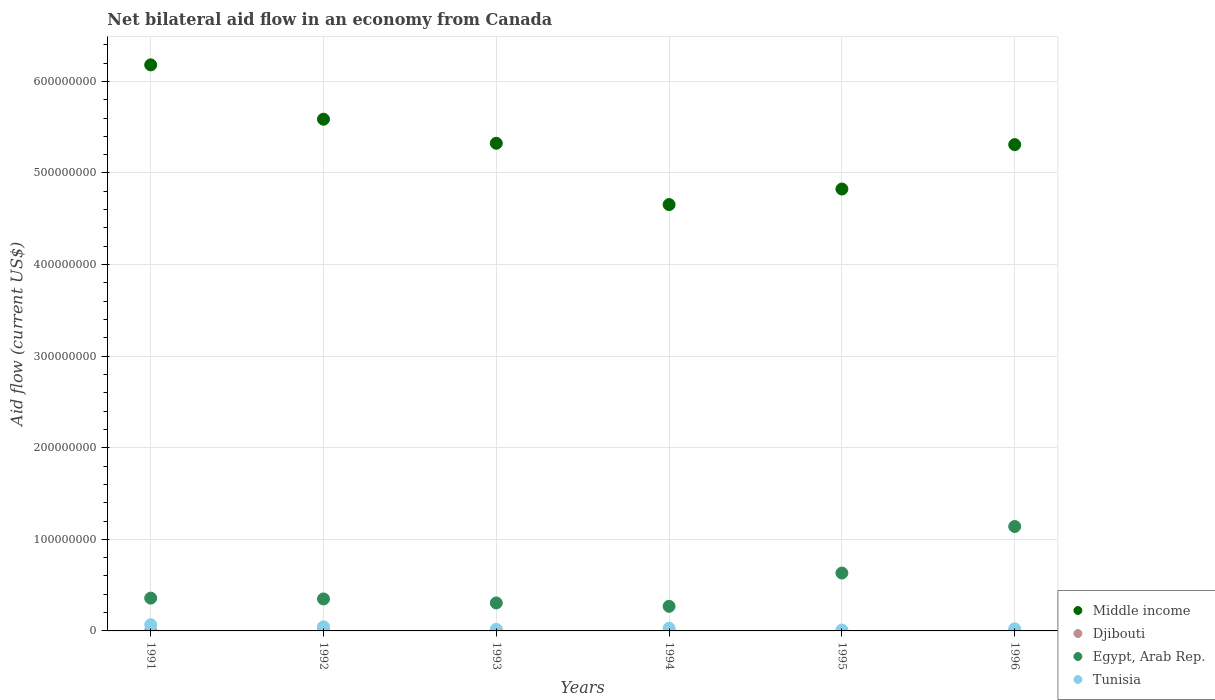How many different coloured dotlines are there?
Offer a very short reply. 4. What is the net bilateral aid flow in Tunisia in 1992?
Your answer should be very brief. 4.51e+06. Across all years, what is the maximum net bilateral aid flow in Tunisia?
Offer a terse response. 6.78e+06. Across all years, what is the minimum net bilateral aid flow in Tunisia?
Ensure brevity in your answer.  9.30e+05. In which year was the net bilateral aid flow in Egypt, Arab Rep. maximum?
Offer a very short reply. 1996. In which year was the net bilateral aid flow in Middle income minimum?
Ensure brevity in your answer.  1994. What is the total net bilateral aid flow in Djibouti in the graph?
Provide a short and direct response. 1.22e+06. What is the difference between the net bilateral aid flow in Djibouti in 1991 and that in 1992?
Your answer should be very brief. -2.40e+05. What is the difference between the net bilateral aid flow in Middle income in 1994 and the net bilateral aid flow in Egypt, Arab Rep. in 1992?
Make the answer very short. 4.31e+08. What is the average net bilateral aid flow in Egypt, Arab Rep. per year?
Your answer should be compact. 5.09e+07. In the year 1992, what is the difference between the net bilateral aid flow in Djibouti and net bilateral aid flow in Egypt, Arab Rep.?
Your answer should be compact. -3.45e+07. What is the ratio of the net bilateral aid flow in Djibouti in 1993 to that in 1996?
Ensure brevity in your answer.  1.47. Is the net bilateral aid flow in Middle income in 1994 less than that in 1995?
Offer a very short reply. Yes. Is the difference between the net bilateral aid flow in Djibouti in 1993 and 1996 greater than the difference between the net bilateral aid flow in Egypt, Arab Rep. in 1993 and 1996?
Your answer should be very brief. Yes. What is the difference between the highest and the lowest net bilateral aid flow in Middle income?
Provide a succinct answer. 1.53e+08. Is it the case that in every year, the sum of the net bilateral aid flow in Tunisia and net bilateral aid flow in Egypt, Arab Rep.  is greater than the net bilateral aid flow in Middle income?
Provide a succinct answer. No. Is the net bilateral aid flow in Egypt, Arab Rep. strictly greater than the net bilateral aid flow in Djibouti over the years?
Your answer should be compact. Yes. Is the net bilateral aid flow in Tunisia strictly less than the net bilateral aid flow in Djibouti over the years?
Your answer should be compact. No. How many dotlines are there?
Provide a short and direct response. 4. What is the difference between two consecutive major ticks on the Y-axis?
Provide a succinct answer. 1.00e+08. Are the values on the major ticks of Y-axis written in scientific E-notation?
Offer a terse response. No. Does the graph contain any zero values?
Your answer should be very brief. No. Does the graph contain grids?
Your answer should be compact. Yes. How many legend labels are there?
Provide a short and direct response. 4. How are the legend labels stacked?
Provide a short and direct response. Vertical. What is the title of the graph?
Keep it short and to the point. Net bilateral aid flow in an economy from Canada. Does "Papua New Guinea" appear as one of the legend labels in the graph?
Keep it short and to the point. No. What is the label or title of the X-axis?
Your answer should be compact. Years. What is the label or title of the Y-axis?
Your response must be concise. Aid flow (current US$). What is the Aid flow (current US$) of Middle income in 1991?
Your answer should be compact. 6.18e+08. What is the Aid flow (current US$) of Egypt, Arab Rep. in 1991?
Provide a succinct answer. 3.58e+07. What is the Aid flow (current US$) in Tunisia in 1991?
Offer a terse response. 6.78e+06. What is the Aid flow (current US$) in Middle income in 1992?
Offer a terse response. 5.59e+08. What is the Aid flow (current US$) of Egypt, Arab Rep. in 1992?
Give a very brief answer. 3.49e+07. What is the Aid flow (current US$) in Tunisia in 1992?
Offer a terse response. 4.51e+06. What is the Aid flow (current US$) of Middle income in 1993?
Make the answer very short. 5.32e+08. What is the Aid flow (current US$) in Djibouti in 1993?
Keep it short and to the point. 2.20e+05. What is the Aid flow (current US$) of Egypt, Arab Rep. in 1993?
Offer a very short reply. 3.05e+07. What is the Aid flow (current US$) of Tunisia in 1993?
Your response must be concise. 1.77e+06. What is the Aid flow (current US$) in Middle income in 1994?
Ensure brevity in your answer.  4.66e+08. What is the Aid flow (current US$) of Djibouti in 1994?
Make the answer very short. 1.30e+05. What is the Aid flow (current US$) of Egypt, Arab Rep. in 1994?
Give a very brief answer. 2.69e+07. What is the Aid flow (current US$) in Tunisia in 1994?
Your answer should be compact. 2.89e+06. What is the Aid flow (current US$) in Middle income in 1995?
Provide a short and direct response. 4.82e+08. What is the Aid flow (current US$) of Djibouti in 1995?
Your response must be concise. 1.40e+05. What is the Aid flow (current US$) in Egypt, Arab Rep. in 1995?
Offer a very short reply. 6.32e+07. What is the Aid flow (current US$) in Tunisia in 1995?
Provide a short and direct response. 9.30e+05. What is the Aid flow (current US$) in Middle income in 1996?
Your response must be concise. 5.31e+08. What is the Aid flow (current US$) in Egypt, Arab Rep. in 1996?
Make the answer very short. 1.14e+08. What is the Aid flow (current US$) of Tunisia in 1996?
Ensure brevity in your answer.  2.28e+06. Across all years, what is the maximum Aid flow (current US$) in Middle income?
Your answer should be very brief. 6.18e+08. Across all years, what is the maximum Aid flow (current US$) in Egypt, Arab Rep.?
Provide a succinct answer. 1.14e+08. Across all years, what is the maximum Aid flow (current US$) in Tunisia?
Provide a short and direct response. 6.78e+06. Across all years, what is the minimum Aid flow (current US$) of Middle income?
Make the answer very short. 4.66e+08. Across all years, what is the minimum Aid flow (current US$) in Djibouti?
Provide a succinct answer. 1.30e+05. Across all years, what is the minimum Aid flow (current US$) in Egypt, Arab Rep.?
Ensure brevity in your answer.  2.69e+07. Across all years, what is the minimum Aid flow (current US$) of Tunisia?
Provide a succinct answer. 9.30e+05. What is the total Aid flow (current US$) of Middle income in the graph?
Provide a short and direct response. 3.19e+09. What is the total Aid flow (current US$) in Djibouti in the graph?
Keep it short and to the point. 1.22e+06. What is the total Aid flow (current US$) of Egypt, Arab Rep. in the graph?
Provide a short and direct response. 3.05e+08. What is the total Aid flow (current US$) of Tunisia in the graph?
Your answer should be very brief. 1.92e+07. What is the difference between the Aid flow (current US$) of Middle income in 1991 and that in 1992?
Your response must be concise. 5.93e+07. What is the difference between the Aid flow (current US$) in Egypt, Arab Rep. in 1991 and that in 1992?
Make the answer very short. 9.00e+05. What is the difference between the Aid flow (current US$) in Tunisia in 1991 and that in 1992?
Your answer should be compact. 2.27e+06. What is the difference between the Aid flow (current US$) in Middle income in 1991 and that in 1993?
Provide a short and direct response. 8.56e+07. What is the difference between the Aid flow (current US$) of Egypt, Arab Rep. in 1991 and that in 1993?
Your response must be concise. 5.28e+06. What is the difference between the Aid flow (current US$) of Tunisia in 1991 and that in 1993?
Keep it short and to the point. 5.01e+06. What is the difference between the Aid flow (current US$) of Middle income in 1991 and that in 1994?
Your response must be concise. 1.53e+08. What is the difference between the Aid flow (current US$) in Djibouti in 1991 and that in 1994?
Your response must be concise. 4.00e+04. What is the difference between the Aid flow (current US$) in Egypt, Arab Rep. in 1991 and that in 1994?
Your answer should be very brief. 8.95e+06. What is the difference between the Aid flow (current US$) in Tunisia in 1991 and that in 1994?
Ensure brevity in your answer.  3.89e+06. What is the difference between the Aid flow (current US$) in Middle income in 1991 and that in 1995?
Provide a short and direct response. 1.36e+08. What is the difference between the Aid flow (current US$) of Djibouti in 1991 and that in 1995?
Make the answer very short. 3.00e+04. What is the difference between the Aid flow (current US$) of Egypt, Arab Rep. in 1991 and that in 1995?
Make the answer very short. -2.74e+07. What is the difference between the Aid flow (current US$) of Tunisia in 1991 and that in 1995?
Keep it short and to the point. 5.85e+06. What is the difference between the Aid flow (current US$) of Middle income in 1991 and that in 1996?
Your answer should be compact. 8.71e+07. What is the difference between the Aid flow (current US$) of Djibouti in 1991 and that in 1996?
Your answer should be compact. 2.00e+04. What is the difference between the Aid flow (current US$) of Egypt, Arab Rep. in 1991 and that in 1996?
Provide a succinct answer. -7.82e+07. What is the difference between the Aid flow (current US$) in Tunisia in 1991 and that in 1996?
Provide a short and direct response. 4.50e+06. What is the difference between the Aid flow (current US$) of Middle income in 1992 and that in 1993?
Your answer should be very brief. 2.63e+07. What is the difference between the Aid flow (current US$) in Djibouti in 1992 and that in 1993?
Provide a succinct answer. 1.90e+05. What is the difference between the Aid flow (current US$) in Egypt, Arab Rep. in 1992 and that in 1993?
Ensure brevity in your answer.  4.38e+06. What is the difference between the Aid flow (current US$) in Tunisia in 1992 and that in 1993?
Your answer should be very brief. 2.74e+06. What is the difference between the Aid flow (current US$) of Middle income in 1992 and that in 1994?
Make the answer very short. 9.32e+07. What is the difference between the Aid flow (current US$) of Djibouti in 1992 and that in 1994?
Offer a very short reply. 2.80e+05. What is the difference between the Aid flow (current US$) of Egypt, Arab Rep. in 1992 and that in 1994?
Provide a short and direct response. 8.05e+06. What is the difference between the Aid flow (current US$) of Tunisia in 1992 and that in 1994?
Offer a very short reply. 1.62e+06. What is the difference between the Aid flow (current US$) in Middle income in 1992 and that in 1995?
Ensure brevity in your answer.  7.62e+07. What is the difference between the Aid flow (current US$) of Egypt, Arab Rep. in 1992 and that in 1995?
Give a very brief answer. -2.83e+07. What is the difference between the Aid flow (current US$) in Tunisia in 1992 and that in 1995?
Provide a succinct answer. 3.58e+06. What is the difference between the Aid flow (current US$) in Middle income in 1992 and that in 1996?
Make the answer very short. 2.78e+07. What is the difference between the Aid flow (current US$) of Egypt, Arab Rep. in 1992 and that in 1996?
Offer a very short reply. -7.91e+07. What is the difference between the Aid flow (current US$) in Tunisia in 1992 and that in 1996?
Ensure brevity in your answer.  2.23e+06. What is the difference between the Aid flow (current US$) of Middle income in 1993 and that in 1994?
Make the answer very short. 6.69e+07. What is the difference between the Aid flow (current US$) of Djibouti in 1993 and that in 1994?
Give a very brief answer. 9.00e+04. What is the difference between the Aid flow (current US$) of Egypt, Arab Rep. in 1993 and that in 1994?
Your answer should be compact. 3.67e+06. What is the difference between the Aid flow (current US$) in Tunisia in 1993 and that in 1994?
Give a very brief answer. -1.12e+06. What is the difference between the Aid flow (current US$) of Middle income in 1993 and that in 1995?
Keep it short and to the point. 4.99e+07. What is the difference between the Aid flow (current US$) in Egypt, Arab Rep. in 1993 and that in 1995?
Provide a succinct answer. -3.26e+07. What is the difference between the Aid flow (current US$) of Tunisia in 1993 and that in 1995?
Provide a succinct answer. 8.40e+05. What is the difference between the Aid flow (current US$) in Middle income in 1993 and that in 1996?
Offer a terse response. 1.48e+06. What is the difference between the Aid flow (current US$) in Djibouti in 1993 and that in 1996?
Provide a succinct answer. 7.00e+04. What is the difference between the Aid flow (current US$) of Egypt, Arab Rep. in 1993 and that in 1996?
Keep it short and to the point. -8.35e+07. What is the difference between the Aid flow (current US$) of Tunisia in 1993 and that in 1996?
Make the answer very short. -5.10e+05. What is the difference between the Aid flow (current US$) in Middle income in 1994 and that in 1995?
Your response must be concise. -1.70e+07. What is the difference between the Aid flow (current US$) in Egypt, Arab Rep. in 1994 and that in 1995?
Keep it short and to the point. -3.63e+07. What is the difference between the Aid flow (current US$) in Tunisia in 1994 and that in 1995?
Keep it short and to the point. 1.96e+06. What is the difference between the Aid flow (current US$) in Middle income in 1994 and that in 1996?
Give a very brief answer. -6.54e+07. What is the difference between the Aid flow (current US$) of Djibouti in 1994 and that in 1996?
Your answer should be very brief. -2.00e+04. What is the difference between the Aid flow (current US$) in Egypt, Arab Rep. in 1994 and that in 1996?
Your response must be concise. -8.72e+07. What is the difference between the Aid flow (current US$) of Tunisia in 1994 and that in 1996?
Offer a terse response. 6.10e+05. What is the difference between the Aid flow (current US$) of Middle income in 1995 and that in 1996?
Ensure brevity in your answer.  -4.85e+07. What is the difference between the Aid flow (current US$) in Djibouti in 1995 and that in 1996?
Provide a short and direct response. -10000. What is the difference between the Aid flow (current US$) in Egypt, Arab Rep. in 1995 and that in 1996?
Keep it short and to the point. -5.08e+07. What is the difference between the Aid flow (current US$) in Tunisia in 1995 and that in 1996?
Provide a short and direct response. -1.35e+06. What is the difference between the Aid flow (current US$) in Middle income in 1991 and the Aid flow (current US$) in Djibouti in 1992?
Offer a terse response. 6.18e+08. What is the difference between the Aid flow (current US$) in Middle income in 1991 and the Aid flow (current US$) in Egypt, Arab Rep. in 1992?
Give a very brief answer. 5.83e+08. What is the difference between the Aid flow (current US$) of Middle income in 1991 and the Aid flow (current US$) of Tunisia in 1992?
Provide a succinct answer. 6.14e+08. What is the difference between the Aid flow (current US$) in Djibouti in 1991 and the Aid flow (current US$) in Egypt, Arab Rep. in 1992?
Offer a terse response. -3.48e+07. What is the difference between the Aid flow (current US$) in Djibouti in 1991 and the Aid flow (current US$) in Tunisia in 1992?
Keep it short and to the point. -4.34e+06. What is the difference between the Aid flow (current US$) of Egypt, Arab Rep. in 1991 and the Aid flow (current US$) of Tunisia in 1992?
Make the answer very short. 3.13e+07. What is the difference between the Aid flow (current US$) of Middle income in 1991 and the Aid flow (current US$) of Djibouti in 1993?
Provide a short and direct response. 6.18e+08. What is the difference between the Aid flow (current US$) of Middle income in 1991 and the Aid flow (current US$) of Egypt, Arab Rep. in 1993?
Give a very brief answer. 5.87e+08. What is the difference between the Aid flow (current US$) of Middle income in 1991 and the Aid flow (current US$) of Tunisia in 1993?
Provide a short and direct response. 6.16e+08. What is the difference between the Aid flow (current US$) of Djibouti in 1991 and the Aid flow (current US$) of Egypt, Arab Rep. in 1993?
Keep it short and to the point. -3.04e+07. What is the difference between the Aid flow (current US$) in Djibouti in 1991 and the Aid flow (current US$) in Tunisia in 1993?
Offer a terse response. -1.60e+06. What is the difference between the Aid flow (current US$) of Egypt, Arab Rep. in 1991 and the Aid flow (current US$) of Tunisia in 1993?
Your answer should be compact. 3.40e+07. What is the difference between the Aid flow (current US$) of Middle income in 1991 and the Aid flow (current US$) of Djibouti in 1994?
Ensure brevity in your answer.  6.18e+08. What is the difference between the Aid flow (current US$) in Middle income in 1991 and the Aid flow (current US$) in Egypt, Arab Rep. in 1994?
Your response must be concise. 5.91e+08. What is the difference between the Aid flow (current US$) in Middle income in 1991 and the Aid flow (current US$) in Tunisia in 1994?
Offer a terse response. 6.15e+08. What is the difference between the Aid flow (current US$) in Djibouti in 1991 and the Aid flow (current US$) in Egypt, Arab Rep. in 1994?
Give a very brief answer. -2.67e+07. What is the difference between the Aid flow (current US$) of Djibouti in 1991 and the Aid flow (current US$) of Tunisia in 1994?
Ensure brevity in your answer.  -2.72e+06. What is the difference between the Aid flow (current US$) in Egypt, Arab Rep. in 1991 and the Aid flow (current US$) in Tunisia in 1994?
Your response must be concise. 3.29e+07. What is the difference between the Aid flow (current US$) of Middle income in 1991 and the Aid flow (current US$) of Djibouti in 1995?
Keep it short and to the point. 6.18e+08. What is the difference between the Aid flow (current US$) in Middle income in 1991 and the Aid flow (current US$) in Egypt, Arab Rep. in 1995?
Provide a short and direct response. 5.55e+08. What is the difference between the Aid flow (current US$) of Middle income in 1991 and the Aid flow (current US$) of Tunisia in 1995?
Offer a very short reply. 6.17e+08. What is the difference between the Aid flow (current US$) of Djibouti in 1991 and the Aid flow (current US$) of Egypt, Arab Rep. in 1995?
Keep it short and to the point. -6.30e+07. What is the difference between the Aid flow (current US$) of Djibouti in 1991 and the Aid flow (current US$) of Tunisia in 1995?
Give a very brief answer. -7.60e+05. What is the difference between the Aid flow (current US$) of Egypt, Arab Rep. in 1991 and the Aid flow (current US$) of Tunisia in 1995?
Give a very brief answer. 3.49e+07. What is the difference between the Aid flow (current US$) of Middle income in 1991 and the Aid flow (current US$) of Djibouti in 1996?
Offer a very short reply. 6.18e+08. What is the difference between the Aid flow (current US$) of Middle income in 1991 and the Aid flow (current US$) of Egypt, Arab Rep. in 1996?
Offer a terse response. 5.04e+08. What is the difference between the Aid flow (current US$) of Middle income in 1991 and the Aid flow (current US$) of Tunisia in 1996?
Ensure brevity in your answer.  6.16e+08. What is the difference between the Aid flow (current US$) of Djibouti in 1991 and the Aid flow (current US$) of Egypt, Arab Rep. in 1996?
Offer a terse response. -1.14e+08. What is the difference between the Aid flow (current US$) of Djibouti in 1991 and the Aid flow (current US$) of Tunisia in 1996?
Provide a succinct answer. -2.11e+06. What is the difference between the Aid flow (current US$) in Egypt, Arab Rep. in 1991 and the Aid flow (current US$) in Tunisia in 1996?
Provide a short and direct response. 3.35e+07. What is the difference between the Aid flow (current US$) of Middle income in 1992 and the Aid flow (current US$) of Djibouti in 1993?
Your response must be concise. 5.58e+08. What is the difference between the Aid flow (current US$) of Middle income in 1992 and the Aid flow (current US$) of Egypt, Arab Rep. in 1993?
Ensure brevity in your answer.  5.28e+08. What is the difference between the Aid flow (current US$) in Middle income in 1992 and the Aid flow (current US$) in Tunisia in 1993?
Your answer should be compact. 5.57e+08. What is the difference between the Aid flow (current US$) in Djibouti in 1992 and the Aid flow (current US$) in Egypt, Arab Rep. in 1993?
Provide a short and direct response. -3.01e+07. What is the difference between the Aid flow (current US$) of Djibouti in 1992 and the Aid flow (current US$) of Tunisia in 1993?
Offer a very short reply. -1.36e+06. What is the difference between the Aid flow (current US$) of Egypt, Arab Rep. in 1992 and the Aid flow (current US$) of Tunisia in 1993?
Offer a terse response. 3.32e+07. What is the difference between the Aid flow (current US$) in Middle income in 1992 and the Aid flow (current US$) in Djibouti in 1994?
Your answer should be very brief. 5.59e+08. What is the difference between the Aid flow (current US$) of Middle income in 1992 and the Aid flow (current US$) of Egypt, Arab Rep. in 1994?
Your response must be concise. 5.32e+08. What is the difference between the Aid flow (current US$) of Middle income in 1992 and the Aid flow (current US$) of Tunisia in 1994?
Keep it short and to the point. 5.56e+08. What is the difference between the Aid flow (current US$) of Djibouti in 1992 and the Aid flow (current US$) of Egypt, Arab Rep. in 1994?
Your response must be concise. -2.65e+07. What is the difference between the Aid flow (current US$) of Djibouti in 1992 and the Aid flow (current US$) of Tunisia in 1994?
Your answer should be very brief. -2.48e+06. What is the difference between the Aid flow (current US$) in Egypt, Arab Rep. in 1992 and the Aid flow (current US$) in Tunisia in 1994?
Your response must be concise. 3.20e+07. What is the difference between the Aid flow (current US$) of Middle income in 1992 and the Aid flow (current US$) of Djibouti in 1995?
Keep it short and to the point. 5.59e+08. What is the difference between the Aid flow (current US$) in Middle income in 1992 and the Aid flow (current US$) in Egypt, Arab Rep. in 1995?
Offer a very short reply. 4.96e+08. What is the difference between the Aid flow (current US$) of Middle income in 1992 and the Aid flow (current US$) of Tunisia in 1995?
Your answer should be very brief. 5.58e+08. What is the difference between the Aid flow (current US$) of Djibouti in 1992 and the Aid flow (current US$) of Egypt, Arab Rep. in 1995?
Your response must be concise. -6.28e+07. What is the difference between the Aid flow (current US$) in Djibouti in 1992 and the Aid flow (current US$) in Tunisia in 1995?
Your response must be concise. -5.20e+05. What is the difference between the Aid flow (current US$) in Egypt, Arab Rep. in 1992 and the Aid flow (current US$) in Tunisia in 1995?
Your answer should be very brief. 3.40e+07. What is the difference between the Aid flow (current US$) of Middle income in 1992 and the Aid flow (current US$) of Djibouti in 1996?
Ensure brevity in your answer.  5.59e+08. What is the difference between the Aid flow (current US$) of Middle income in 1992 and the Aid flow (current US$) of Egypt, Arab Rep. in 1996?
Your answer should be compact. 4.45e+08. What is the difference between the Aid flow (current US$) in Middle income in 1992 and the Aid flow (current US$) in Tunisia in 1996?
Your answer should be compact. 5.56e+08. What is the difference between the Aid flow (current US$) of Djibouti in 1992 and the Aid flow (current US$) of Egypt, Arab Rep. in 1996?
Make the answer very short. -1.14e+08. What is the difference between the Aid flow (current US$) of Djibouti in 1992 and the Aid flow (current US$) of Tunisia in 1996?
Keep it short and to the point. -1.87e+06. What is the difference between the Aid flow (current US$) in Egypt, Arab Rep. in 1992 and the Aid flow (current US$) in Tunisia in 1996?
Give a very brief answer. 3.26e+07. What is the difference between the Aid flow (current US$) of Middle income in 1993 and the Aid flow (current US$) of Djibouti in 1994?
Your answer should be compact. 5.32e+08. What is the difference between the Aid flow (current US$) in Middle income in 1993 and the Aid flow (current US$) in Egypt, Arab Rep. in 1994?
Offer a terse response. 5.06e+08. What is the difference between the Aid flow (current US$) of Middle income in 1993 and the Aid flow (current US$) of Tunisia in 1994?
Ensure brevity in your answer.  5.30e+08. What is the difference between the Aid flow (current US$) of Djibouti in 1993 and the Aid flow (current US$) of Egypt, Arab Rep. in 1994?
Your answer should be compact. -2.66e+07. What is the difference between the Aid flow (current US$) of Djibouti in 1993 and the Aid flow (current US$) of Tunisia in 1994?
Provide a short and direct response. -2.67e+06. What is the difference between the Aid flow (current US$) in Egypt, Arab Rep. in 1993 and the Aid flow (current US$) in Tunisia in 1994?
Keep it short and to the point. 2.76e+07. What is the difference between the Aid flow (current US$) in Middle income in 1993 and the Aid flow (current US$) in Djibouti in 1995?
Provide a short and direct response. 5.32e+08. What is the difference between the Aid flow (current US$) in Middle income in 1993 and the Aid flow (current US$) in Egypt, Arab Rep. in 1995?
Ensure brevity in your answer.  4.69e+08. What is the difference between the Aid flow (current US$) in Middle income in 1993 and the Aid flow (current US$) in Tunisia in 1995?
Give a very brief answer. 5.31e+08. What is the difference between the Aid flow (current US$) in Djibouti in 1993 and the Aid flow (current US$) in Egypt, Arab Rep. in 1995?
Keep it short and to the point. -6.30e+07. What is the difference between the Aid flow (current US$) of Djibouti in 1993 and the Aid flow (current US$) of Tunisia in 1995?
Offer a terse response. -7.10e+05. What is the difference between the Aid flow (current US$) of Egypt, Arab Rep. in 1993 and the Aid flow (current US$) of Tunisia in 1995?
Your response must be concise. 2.96e+07. What is the difference between the Aid flow (current US$) in Middle income in 1993 and the Aid flow (current US$) in Djibouti in 1996?
Offer a terse response. 5.32e+08. What is the difference between the Aid flow (current US$) in Middle income in 1993 and the Aid flow (current US$) in Egypt, Arab Rep. in 1996?
Offer a terse response. 4.18e+08. What is the difference between the Aid flow (current US$) of Middle income in 1993 and the Aid flow (current US$) of Tunisia in 1996?
Provide a succinct answer. 5.30e+08. What is the difference between the Aid flow (current US$) in Djibouti in 1993 and the Aid flow (current US$) in Egypt, Arab Rep. in 1996?
Keep it short and to the point. -1.14e+08. What is the difference between the Aid flow (current US$) in Djibouti in 1993 and the Aid flow (current US$) in Tunisia in 1996?
Offer a terse response. -2.06e+06. What is the difference between the Aid flow (current US$) in Egypt, Arab Rep. in 1993 and the Aid flow (current US$) in Tunisia in 1996?
Give a very brief answer. 2.83e+07. What is the difference between the Aid flow (current US$) in Middle income in 1994 and the Aid flow (current US$) in Djibouti in 1995?
Ensure brevity in your answer.  4.65e+08. What is the difference between the Aid flow (current US$) in Middle income in 1994 and the Aid flow (current US$) in Egypt, Arab Rep. in 1995?
Provide a short and direct response. 4.02e+08. What is the difference between the Aid flow (current US$) of Middle income in 1994 and the Aid flow (current US$) of Tunisia in 1995?
Keep it short and to the point. 4.65e+08. What is the difference between the Aid flow (current US$) in Djibouti in 1994 and the Aid flow (current US$) in Egypt, Arab Rep. in 1995?
Provide a succinct answer. -6.31e+07. What is the difference between the Aid flow (current US$) in Djibouti in 1994 and the Aid flow (current US$) in Tunisia in 1995?
Provide a short and direct response. -8.00e+05. What is the difference between the Aid flow (current US$) in Egypt, Arab Rep. in 1994 and the Aid flow (current US$) in Tunisia in 1995?
Offer a terse response. 2.59e+07. What is the difference between the Aid flow (current US$) of Middle income in 1994 and the Aid flow (current US$) of Djibouti in 1996?
Your answer should be compact. 4.65e+08. What is the difference between the Aid flow (current US$) in Middle income in 1994 and the Aid flow (current US$) in Egypt, Arab Rep. in 1996?
Your answer should be compact. 3.51e+08. What is the difference between the Aid flow (current US$) in Middle income in 1994 and the Aid flow (current US$) in Tunisia in 1996?
Offer a terse response. 4.63e+08. What is the difference between the Aid flow (current US$) of Djibouti in 1994 and the Aid flow (current US$) of Egypt, Arab Rep. in 1996?
Keep it short and to the point. -1.14e+08. What is the difference between the Aid flow (current US$) in Djibouti in 1994 and the Aid flow (current US$) in Tunisia in 1996?
Keep it short and to the point. -2.15e+06. What is the difference between the Aid flow (current US$) in Egypt, Arab Rep. in 1994 and the Aid flow (current US$) in Tunisia in 1996?
Make the answer very short. 2.46e+07. What is the difference between the Aid flow (current US$) of Middle income in 1995 and the Aid flow (current US$) of Djibouti in 1996?
Make the answer very short. 4.82e+08. What is the difference between the Aid flow (current US$) in Middle income in 1995 and the Aid flow (current US$) in Egypt, Arab Rep. in 1996?
Make the answer very short. 3.68e+08. What is the difference between the Aid flow (current US$) of Middle income in 1995 and the Aid flow (current US$) of Tunisia in 1996?
Keep it short and to the point. 4.80e+08. What is the difference between the Aid flow (current US$) in Djibouti in 1995 and the Aid flow (current US$) in Egypt, Arab Rep. in 1996?
Keep it short and to the point. -1.14e+08. What is the difference between the Aid flow (current US$) in Djibouti in 1995 and the Aid flow (current US$) in Tunisia in 1996?
Your response must be concise. -2.14e+06. What is the difference between the Aid flow (current US$) of Egypt, Arab Rep. in 1995 and the Aid flow (current US$) of Tunisia in 1996?
Your response must be concise. 6.09e+07. What is the average Aid flow (current US$) in Middle income per year?
Your answer should be very brief. 5.31e+08. What is the average Aid flow (current US$) in Djibouti per year?
Your answer should be compact. 2.03e+05. What is the average Aid flow (current US$) in Egypt, Arab Rep. per year?
Your answer should be compact. 5.09e+07. What is the average Aid flow (current US$) of Tunisia per year?
Your answer should be very brief. 3.19e+06. In the year 1991, what is the difference between the Aid flow (current US$) of Middle income and Aid flow (current US$) of Djibouti?
Your answer should be very brief. 6.18e+08. In the year 1991, what is the difference between the Aid flow (current US$) in Middle income and Aid flow (current US$) in Egypt, Arab Rep.?
Provide a succinct answer. 5.82e+08. In the year 1991, what is the difference between the Aid flow (current US$) in Middle income and Aid flow (current US$) in Tunisia?
Your answer should be very brief. 6.11e+08. In the year 1991, what is the difference between the Aid flow (current US$) in Djibouti and Aid flow (current US$) in Egypt, Arab Rep.?
Your answer should be compact. -3.56e+07. In the year 1991, what is the difference between the Aid flow (current US$) in Djibouti and Aid flow (current US$) in Tunisia?
Offer a very short reply. -6.61e+06. In the year 1991, what is the difference between the Aid flow (current US$) in Egypt, Arab Rep. and Aid flow (current US$) in Tunisia?
Provide a short and direct response. 2.90e+07. In the year 1992, what is the difference between the Aid flow (current US$) in Middle income and Aid flow (current US$) in Djibouti?
Keep it short and to the point. 5.58e+08. In the year 1992, what is the difference between the Aid flow (current US$) of Middle income and Aid flow (current US$) of Egypt, Arab Rep.?
Your answer should be very brief. 5.24e+08. In the year 1992, what is the difference between the Aid flow (current US$) in Middle income and Aid flow (current US$) in Tunisia?
Provide a short and direct response. 5.54e+08. In the year 1992, what is the difference between the Aid flow (current US$) in Djibouti and Aid flow (current US$) in Egypt, Arab Rep.?
Ensure brevity in your answer.  -3.45e+07. In the year 1992, what is the difference between the Aid flow (current US$) of Djibouti and Aid flow (current US$) of Tunisia?
Give a very brief answer. -4.10e+06. In the year 1992, what is the difference between the Aid flow (current US$) of Egypt, Arab Rep. and Aid flow (current US$) of Tunisia?
Offer a terse response. 3.04e+07. In the year 1993, what is the difference between the Aid flow (current US$) of Middle income and Aid flow (current US$) of Djibouti?
Provide a short and direct response. 5.32e+08. In the year 1993, what is the difference between the Aid flow (current US$) in Middle income and Aid flow (current US$) in Egypt, Arab Rep.?
Provide a succinct answer. 5.02e+08. In the year 1993, what is the difference between the Aid flow (current US$) of Middle income and Aid flow (current US$) of Tunisia?
Your answer should be compact. 5.31e+08. In the year 1993, what is the difference between the Aid flow (current US$) in Djibouti and Aid flow (current US$) in Egypt, Arab Rep.?
Your response must be concise. -3.03e+07. In the year 1993, what is the difference between the Aid flow (current US$) in Djibouti and Aid flow (current US$) in Tunisia?
Your answer should be very brief. -1.55e+06. In the year 1993, what is the difference between the Aid flow (current US$) in Egypt, Arab Rep. and Aid flow (current US$) in Tunisia?
Make the answer very short. 2.88e+07. In the year 1994, what is the difference between the Aid flow (current US$) in Middle income and Aid flow (current US$) in Djibouti?
Your answer should be very brief. 4.65e+08. In the year 1994, what is the difference between the Aid flow (current US$) of Middle income and Aid flow (current US$) of Egypt, Arab Rep.?
Provide a short and direct response. 4.39e+08. In the year 1994, what is the difference between the Aid flow (current US$) in Middle income and Aid flow (current US$) in Tunisia?
Ensure brevity in your answer.  4.63e+08. In the year 1994, what is the difference between the Aid flow (current US$) in Djibouti and Aid flow (current US$) in Egypt, Arab Rep.?
Keep it short and to the point. -2.67e+07. In the year 1994, what is the difference between the Aid flow (current US$) in Djibouti and Aid flow (current US$) in Tunisia?
Keep it short and to the point. -2.76e+06. In the year 1994, what is the difference between the Aid flow (current US$) in Egypt, Arab Rep. and Aid flow (current US$) in Tunisia?
Provide a short and direct response. 2.40e+07. In the year 1995, what is the difference between the Aid flow (current US$) of Middle income and Aid flow (current US$) of Djibouti?
Give a very brief answer. 4.82e+08. In the year 1995, what is the difference between the Aid flow (current US$) in Middle income and Aid flow (current US$) in Egypt, Arab Rep.?
Your answer should be very brief. 4.19e+08. In the year 1995, what is the difference between the Aid flow (current US$) of Middle income and Aid flow (current US$) of Tunisia?
Offer a terse response. 4.82e+08. In the year 1995, what is the difference between the Aid flow (current US$) in Djibouti and Aid flow (current US$) in Egypt, Arab Rep.?
Offer a terse response. -6.30e+07. In the year 1995, what is the difference between the Aid flow (current US$) of Djibouti and Aid flow (current US$) of Tunisia?
Make the answer very short. -7.90e+05. In the year 1995, what is the difference between the Aid flow (current US$) of Egypt, Arab Rep. and Aid flow (current US$) of Tunisia?
Your answer should be very brief. 6.23e+07. In the year 1996, what is the difference between the Aid flow (current US$) of Middle income and Aid flow (current US$) of Djibouti?
Ensure brevity in your answer.  5.31e+08. In the year 1996, what is the difference between the Aid flow (current US$) of Middle income and Aid flow (current US$) of Egypt, Arab Rep.?
Offer a very short reply. 4.17e+08. In the year 1996, what is the difference between the Aid flow (current US$) of Middle income and Aid flow (current US$) of Tunisia?
Offer a very short reply. 5.29e+08. In the year 1996, what is the difference between the Aid flow (current US$) in Djibouti and Aid flow (current US$) in Egypt, Arab Rep.?
Provide a succinct answer. -1.14e+08. In the year 1996, what is the difference between the Aid flow (current US$) of Djibouti and Aid flow (current US$) of Tunisia?
Your answer should be very brief. -2.13e+06. In the year 1996, what is the difference between the Aid flow (current US$) in Egypt, Arab Rep. and Aid flow (current US$) in Tunisia?
Ensure brevity in your answer.  1.12e+08. What is the ratio of the Aid flow (current US$) in Middle income in 1991 to that in 1992?
Provide a short and direct response. 1.11. What is the ratio of the Aid flow (current US$) of Djibouti in 1991 to that in 1992?
Offer a very short reply. 0.41. What is the ratio of the Aid flow (current US$) of Egypt, Arab Rep. in 1991 to that in 1992?
Your answer should be compact. 1.03. What is the ratio of the Aid flow (current US$) of Tunisia in 1991 to that in 1992?
Give a very brief answer. 1.5. What is the ratio of the Aid flow (current US$) of Middle income in 1991 to that in 1993?
Ensure brevity in your answer.  1.16. What is the ratio of the Aid flow (current US$) in Djibouti in 1991 to that in 1993?
Your answer should be compact. 0.77. What is the ratio of the Aid flow (current US$) of Egypt, Arab Rep. in 1991 to that in 1993?
Offer a terse response. 1.17. What is the ratio of the Aid flow (current US$) in Tunisia in 1991 to that in 1993?
Give a very brief answer. 3.83. What is the ratio of the Aid flow (current US$) of Middle income in 1991 to that in 1994?
Your answer should be very brief. 1.33. What is the ratio of the Aid flow (current US$) in Djibouti in 1991 to that in 1994?
Your answer should be very brief. 1.31. What is the ratio of the Aid flow (current US$) of Egypt, Arab Rep. in 1991 to that in 1994?
Offer a very short reply. 1.33. What is the ratio of the Aid flow (current US$) of Tunisia in 1991 to that in 1994?
Provide a succinct answer. 2.35. What is the ratio of the Aid flow (current US$) in Middle income in 1991 to that in 1995?
Make the answer very short. 1.28. What is the ratio of the Aid flow (current US$) in Djibouti in 1991 to that in 1995?
Your answer should be compact. 1.21. What is the ratio of the Aid flow (current US$) of Egypt, Arab Rep. in 1991 to that in 1995?
Make the answer very short. 0.57. What is the ratio of the Aid flow (current US$) in Tunisia in 1991 to that in 1995?
Your response must be concise. 7.29. What is the ratio of the Aid flow (current US$) in Middle income in 1991 to that in 1996?
Your response must be concise. 1.16. What is the ratio of the Aid flow (current US$) of Djibouti in 1991 to that in 1996?
Your answer should be very brief. 1.13. What is the ratio of the Aid flow (current US$) of Egypt, Arab Rep. in 1991 to that in 1996?
Make the answer very short. 0.31. What is the ratio of the Aid flow (current US$) in Tunisia in 1991 to that in 1996?
Give a very brief answer. 2.97. What is the ratio of the Aid flow (current US$) in Middle income in 1992 to that in 1993?
Make the answer very short. 1.05. What is the ratio of the Aid flow (current US$) of Djibouti in 1992 to that in 1993?
Give a very brief answer. 1.86. What is the ratio of the Aid flow (current US$) of Egypt, Arab Rep. in 1992 to that in 1993?
Your answer should be very brief. 1.14. What is the ratio of the Aid flow (current US$) in Tunisia in 1992 to that in 1993?
Offer a very short reply. 2.55. What is the ratio of the Aid flow (current US$) in Middle income in 1992 to that in 1994?
Make the answer very short. 1.2. What is the ratio of the Aid flow (current US$) in Djibouti in 1992 to that in 1994?
Keep it short and to the point. 3.15. What is the ratio of the Aid flow (current US$) of Egypt, Arab Rep. in 1992 to that in 1994?
Keep it short and to the point. 1.3. What is the ratio of the Aid flow (current US$) of Tunisia in 1992 to that in 1994?
Ensure brevity in your answer.  1.56. What is the ratio of the Aid flow (current US$) of Middle income in 1992 to that in 1995?
Offer a very short reply. 1.16. What is the ratio of the Aid flow (current US$) of Djibouti in 1992 to that in 1995?
Ensure brevity in your answer.  2.93. What is the ratio of the Aid flow (current US$) in Egypt, Arab Rep. in 1992 to that in 1995?
Offer a terse response. 0.55. What is the ratio of the Aid flow (current US$) in Tunisia in 1992 to that in 1995?
Keep it short and to the point. 4.85. What is the ratio of the Aid flow (current US$) in Middle income in 1992 to that in 1996?
Offer a very short reply. 1.05. What is the ratio of the Aid flow (current US$) in Djibouti in 1992 to that in 1996?
Your answer should be compact. 2.73. What is the ratio of the Aid flow (current US$) in Egypt, Arab Rep. in 1992 to that in 1996?
Offer a very short reply. 0.31. What is the ratio of the Aid flow (current US$) in Tunisia in 1992 to that in 1996?
Your response must be concise. 1.98. What is the ratio of the Aid flow (current US$) of Middle income in 1993 to that in 1994?
Ensure brevity in your answer.  1.14. What is the ratio of the Aid flow (current US$) in Djibouti in 1993 to that in 1994?
Your answer should be very brief. 1.69. What is the ratio of the Aid flow (current US$) in Egypt, Arab Rep. in 1993 to that in 1994?
Make the answer very short. 1.14. What is the ratio of the Aid flow (current US$) in Tunisia in 1993 to that in 1994?
Give a very brief answer. 0.61. What is the ratio of the Aid flow (current US$) in Middle income in 1993 to that in 1995?
Offer a terse response. 1.1. What is the ratio of the Aid flow (current US$) in Djibouti in 1993 to that in 1995?
Ensure brevity in your answer.  1.57. What is the ratio of the Aid flow (current US$) in Egypt, Arab Rep. in 1993 to that in 1995?
Give a very brief answer. 0.48. What is the ratio of the Aid flow (current US$) of Tunisia in 1993 to that in 1995?
Keep it short and to the point. 1.9. What is the ratio of the Aid flow (current US$) in Djibouti in 1993 to that in 1996?
Make the answer very short. 1.47. What is the ratio of the Aid flow (current US$) of Egypt, Arab Rep. in 1993 to that in 1996?
Your answer should be compact. 0.27. What is the ratio of the Aid flow (current US$) of Tunisia in 1993 to that in 1996?
Your answer should be very brief. 0.78. What is the ratio of the Aid flow (current US$) of Middle income in 1994 to that in 1995?
Your response must be concise. 0.96. What is the ratio of the Aid flow (current US$) in Djibouti in 1994 to that in 1995?
Give a very brief answer. 0.93. What is the ratio of the Aid flow (current US$) in Egypt, Arab Rep. in 1994 to that in 1995?
Ensure brevity in your answer.  0.43. What is the ratio of the Aid flow (current US$) in Tunisia in 1994 to that in 1995?
Provide a short and direct response. 3.11. What is the ratio of the Aid flow (current US$) in Middle income in 1994 to that in 1996?
Provide a succinct answer. 0.88. What is the ratio of the Aid flow (current US$) of Djibouti in 1994 to that in 1996?
Your answer should be very brief. 0.87. What is the ratio of the Aid flow (current US$) of Egypt, Arab Rep. in 1994 to that in 1996?
Your answer should be very brief. 0.24. What is the ratio of the Aid flow (current US$) of Tunisia in 1994 to that in 1996?
Provide a succinct answer. 1.27. What is the ratio of the Aid flow (current US$) in Middle income in 1995 to that in 1996?
Give a very brief answer. 0.91. What is the ratio of the Aid flow (current US$) in Egypt, Arab Rep. in 1995 to that in 1996?
Keep it short and to the point. 0.55. What is the ratio of the Aid flow (current US$) of Tunisia in 1995 to that in 1996?
Give a very brief answer. 0.41. What is the difference between the highest and the second highest Aid flow (current US$) of Middle income?
Your answer should be compact. 5.93e+07. What is the difference between the highest and the second highest Aid flow (current US$) in Djibouti?
Your response must be concise. 1.90e+05. What is the difference between the highest and the second highest Aid flow (current US$) of Egypt, Arab Rep.?
Keep it short and to the point. 5.08e+07. What is the difference between the highest and the second highest Aid flow (current US$) in Tunisia?
Your answer should be compact. 2.27e+06. What is the difference between the highest and the lowest Aid flow (current US$) in Middle income?
Keep it short and to the point. 1.53e+08. What is the difference between the highest and the lowest Aid flow (current US$) of Egypt, Arab Rep.?
Give a very brief answer. 8.72e+07. What is the difference between the highest and the lowest Aid flow (current US$) of Tunisia?
Make the answer very short. 5.85e+06. 